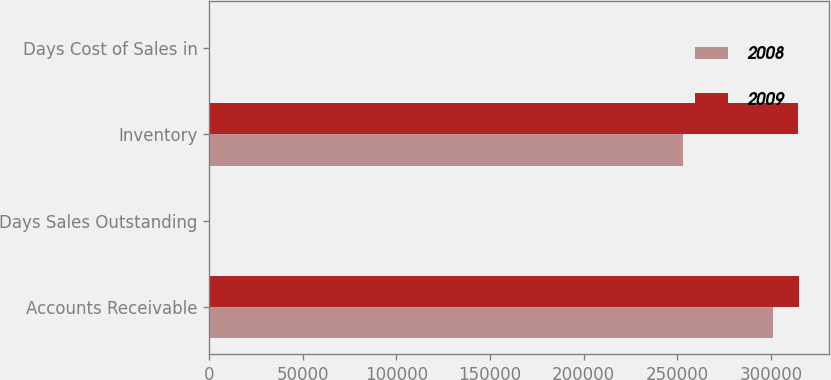Convert chart to OTSL. <chart><loc_0><loc_0><loc_500><loc_500><stacked_bar_chart><ecel><fcel>Accounts Receivable<fcel>Days Sales Outstanding<fcel>Inventory<fcel>Days Cost of Sales in<nl><fcel>2008<fcel>301036<fcel>48<fcel>253161<fcel>92<nl><fcel>2009<fcel>315290<fcel>44<fcel>314629<fcel>112<nl></chart> 